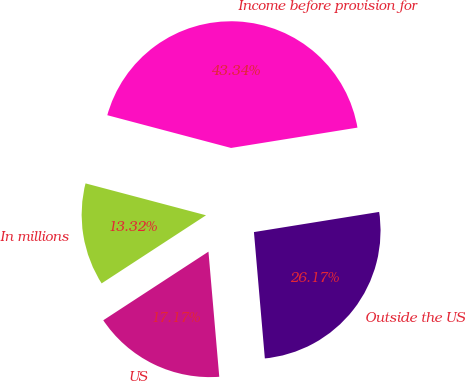Convert chart to OTSL. <chart><loc_0><loc_0><loc_500><loc_500><pie_chart><fcel>In millions<fcel>US<fcel>Outside the US<fcel>Income before provision for<nl><fcel>13.32%<fcel>17.17%<fcel>26.17%<fcel>43.34%<nl></chart> 